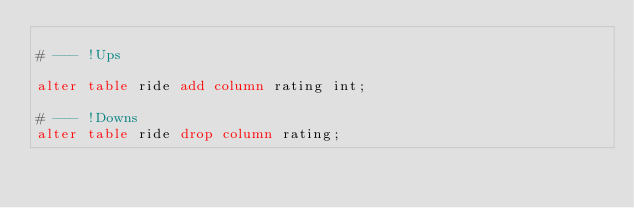<code> <loc_0><loc_0><loc_500><loc_500><_SQL_>
# --- !Ups

alter table ride add column rating int;

# --- !Downs
alter table ride drop column rating;
</code> 